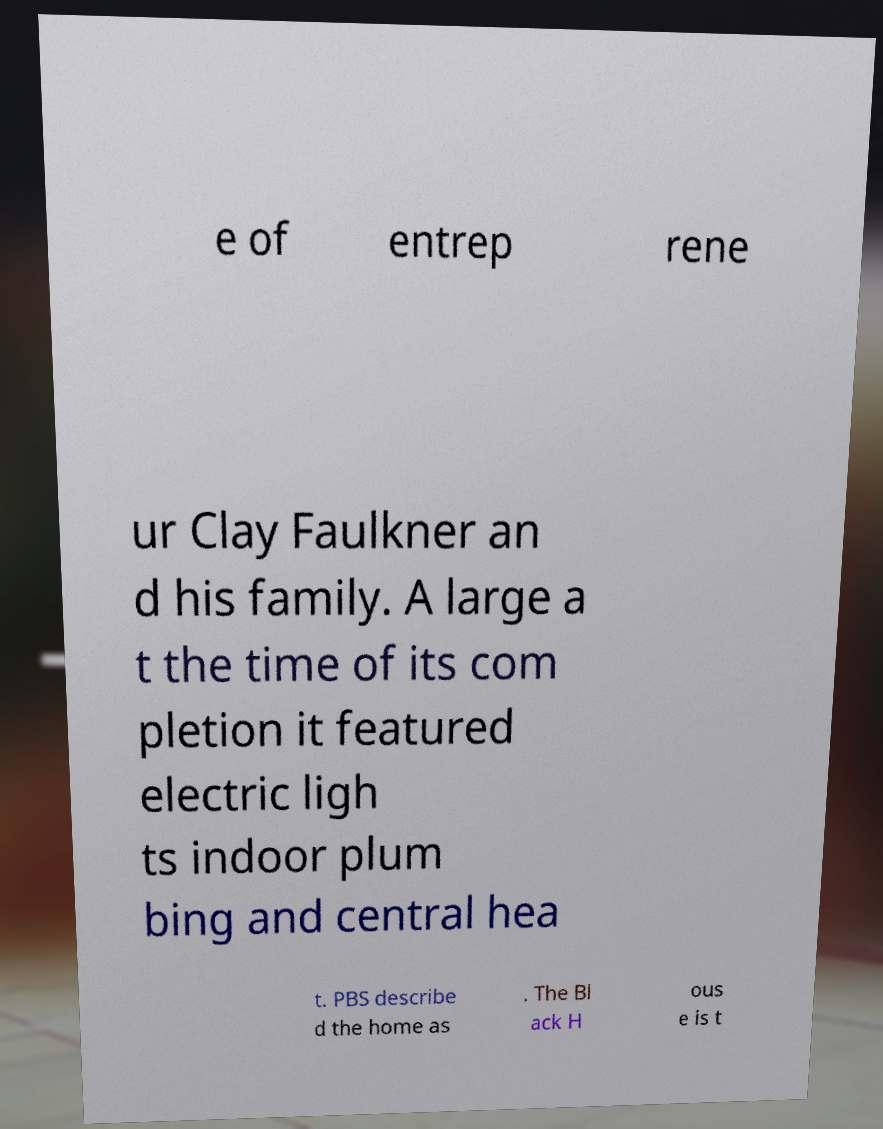Please identify and transcribe the text found in this image. e of entrep rene ur Clay Faulkner an d his family. A large a t the time of its com pletion it featured electric ligh ts indoor plum bing and central hea t. PBS describe d the home as . The Bl ack H ous e is t 